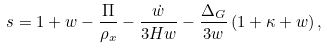Convert formula to latex. <formula><loc_0><loc_0><loc_500><loc_500>s = 1 + w - \frac { \Pi } { \rho _ { x } } - \frac { \dot { w } } { 3 H w } - \frac { \Delta _ { G } } { 3 w } \left ( 1 + \kappa + w \right ) ,</formula> 